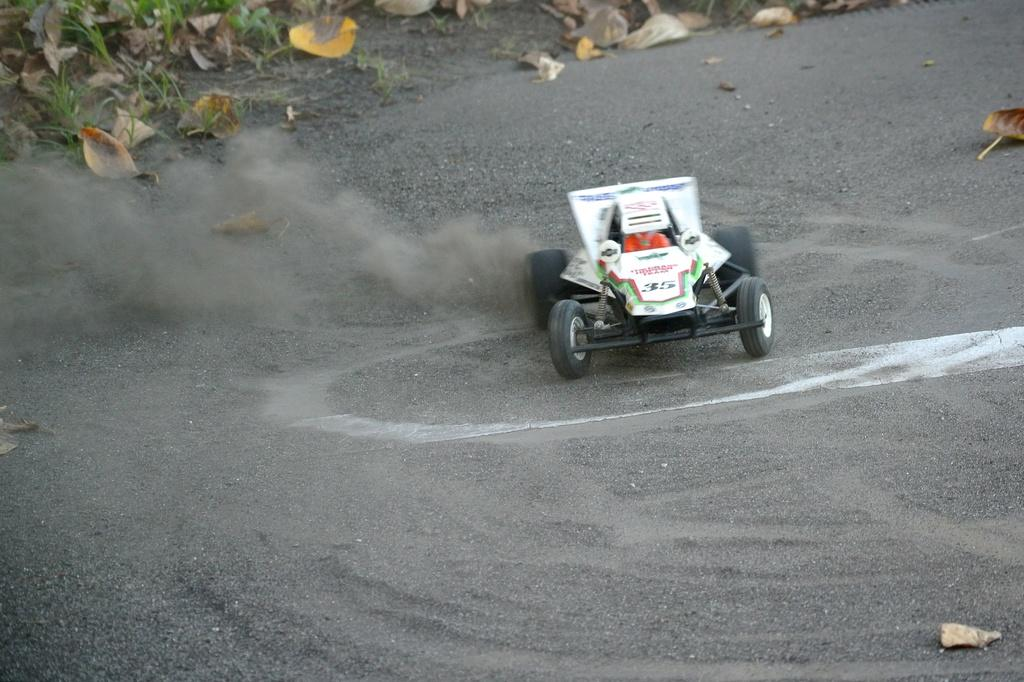What is the main subject in the center of the image? There is a vehicle in the center of the image. What can be seen in the background of the image? There are leaves and grass in the background of the image. What is located at the bottom of the image? There is a walkway at the bottom of the image. How many cherries are on the vehicle in the image? There are no cherries present on the vehicle in the image. What type of dog can be seen walking on the walkway in the image? There is no dog present on the walkway in the image. 